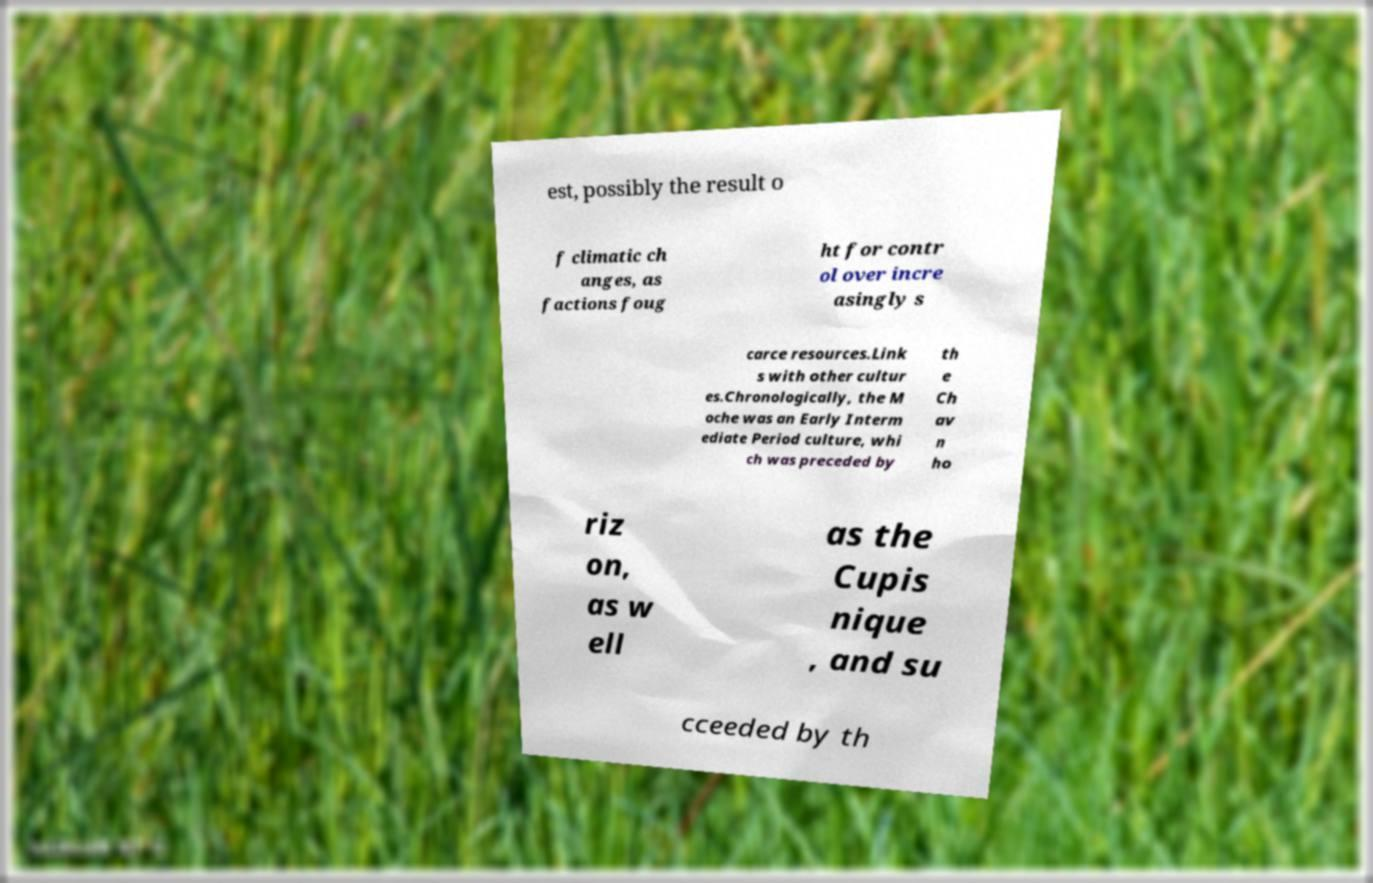Can you accurately transcribe the text from the provided image for me? est, possibly the result o f climatic ch anges, as factions foug ht for contr ol over incre asingly s carce resources.Link s with other cultur es.Chronologically, the M oche was an Early Interm ediate Period culture, whi ch was preceded by th e Ch av n ho riz on, as w ell as the Cupis nique , and su cceeded by th 